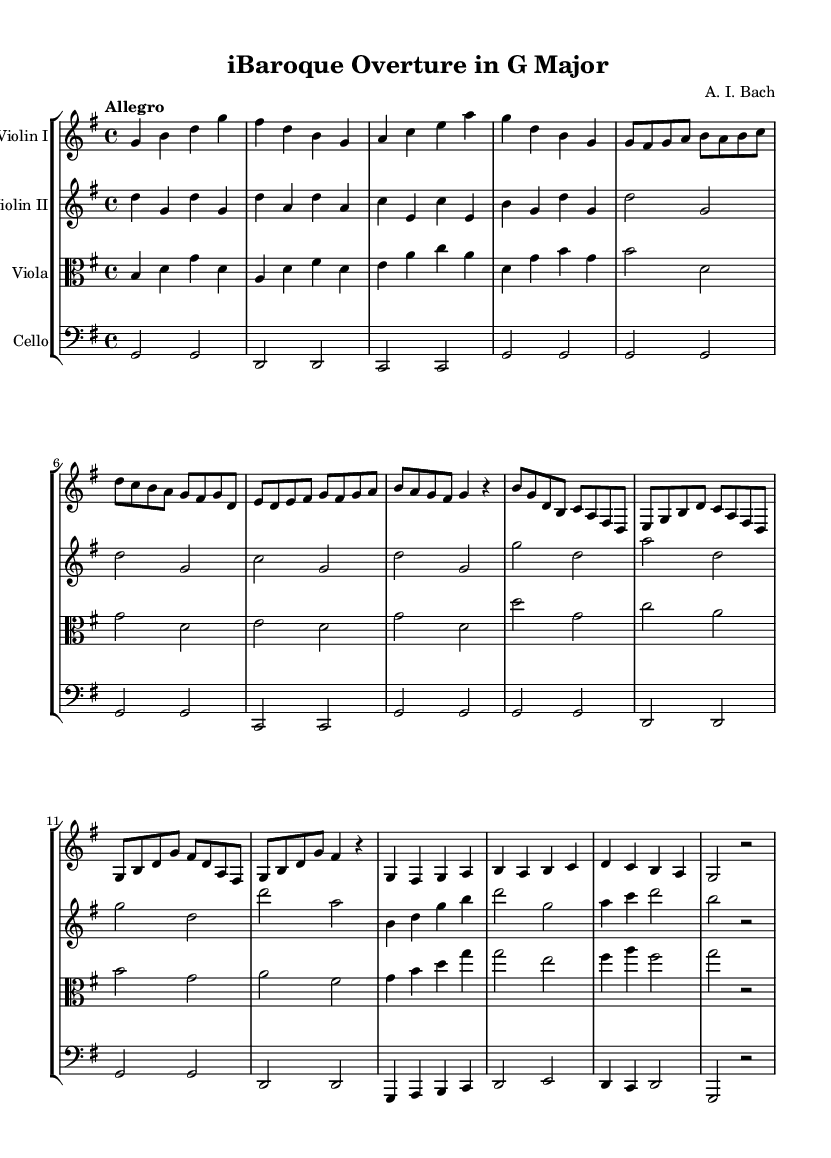What is the key signature of this music? The key signature is G major, which has one sharp (F#). This can be identified by looking at the key signature indicator at the beginning of the score.
Answer: G major What is the time signature of this music? The time signature is 4/4, indicated at the beginning of the score. It shows that there are four beats in each measure, and the quarter note gets one beat.
Answer: 4/4 What is the tempo marking of this music? The tempo marking is "Allegro," which is a term indicating a fast and lively pace. It can be found at the start of the score under the global settings.
Answer: Allegro How many measures are in Theme A? Theme A consists of 8 measures. This can be verified by counting the measures in the section labeled as Theme A within the score.
Answer: 8 Which instruments are featured in this piece? The featured instruments are Violin I, Violin II, Viola, and Cello. The instrument names are listed above each staff in the score.
Answer: Violin I, Violin II, Viola, Cello What is the last note of the piece? The last note of the piece is G, which is found in the final measure as indicated by the notation.
Answer: G What is the form of this piece? The form of the piece is an overture, typically an introductory piece that sets the tone for the following opera. This is characteristic of Baroque opera structure.
Answer: Overture 